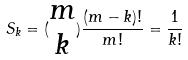Convert formula to latex. <formula><loc_0><loc_0><loc_500><loc_500>S _ { k } = ( \begin{matrix} m \\ k \end{matrix} ) \frac { ( m - k ) ! } { m ! } = \frac { 1 } { k ! }</formula> 